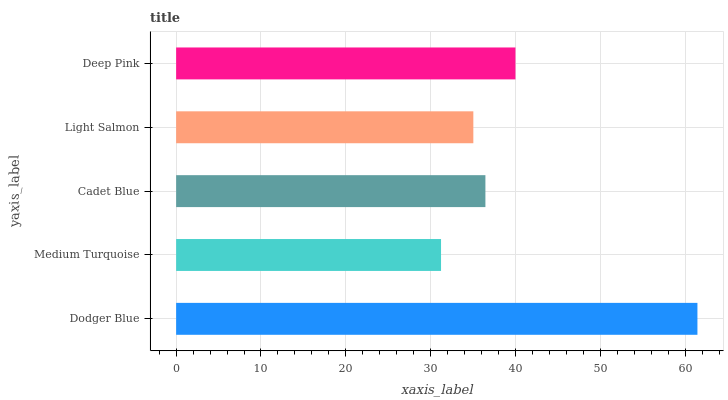Is Medium Turquoise the minimum?
Answer yes or no. Yes. Is Dodger Blue the maximum?
Answer yes or no. Yes. Is Cadet Blue the minimum?
Answer yes or no. No. Is Cadet Blue the maximum?
Answer yes or no. No. Is Cadet Blue greater than Medium Turquoise?
Answer yes or no. Yes. Is Medium Turquoise less than Cadet Blue?
Answer yes or no. Yes. Is Medium Turquoise greater than Cadet Blue?
Answer yes or no. No. Is Cadet Blue less than Medium Turquoise?
Answer yes or no. No. Is Cadet Blue the high median?
Answer yes or no. Yes. Is Cadet Blue the low median?
Answer yes or no. Yes. Is Deep Pink the high median?
Answer yes or no. No. Is Dodger Blue the low median?
Answer yes or no. No. 